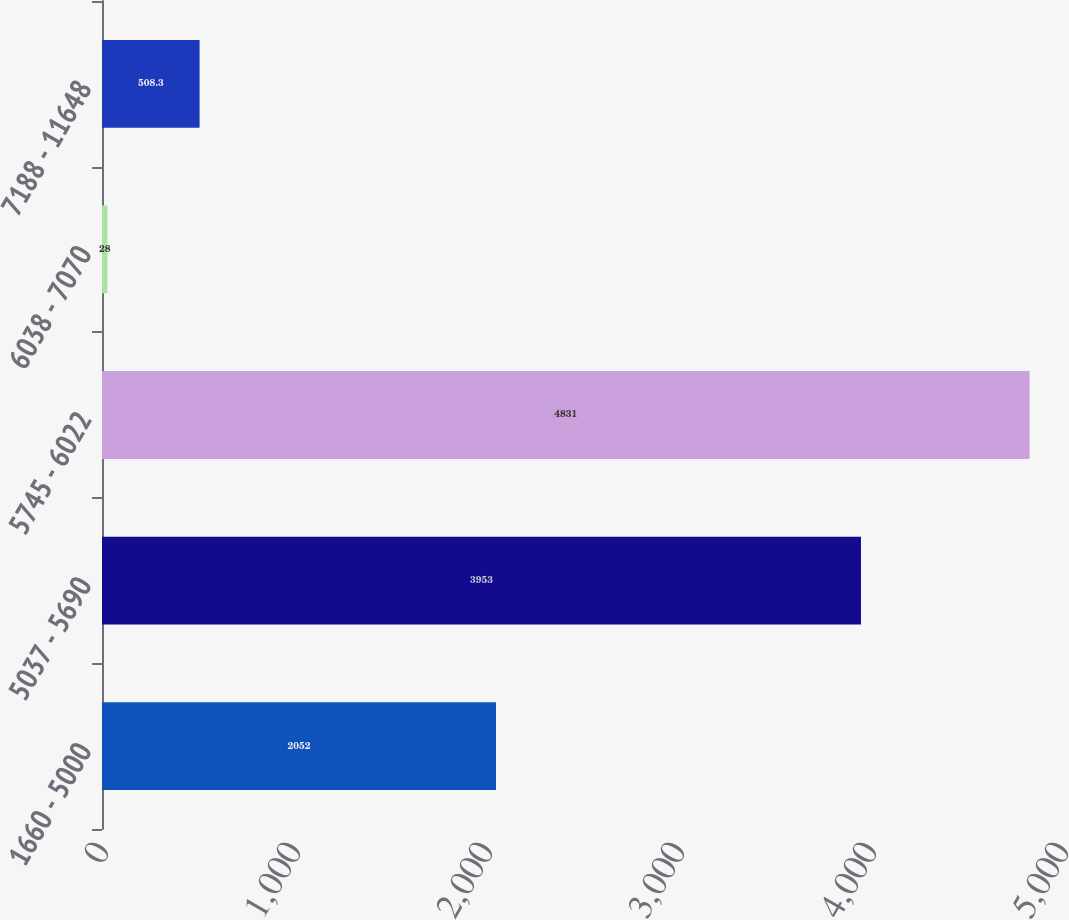Convert chart to OTSL. <chart><loc_0><loc_0><loc_500><loc_500><bar_chart><fcel>1660 - 5000<fcel>5037 - 5690<fcel>5745 - 6022<fcel>6038 - 7070<fcel>7188 - 11648<nl><fcel>2052<fcel>3953<fcel>4831<fcel>28<fcel>508.3<nl></chart> 